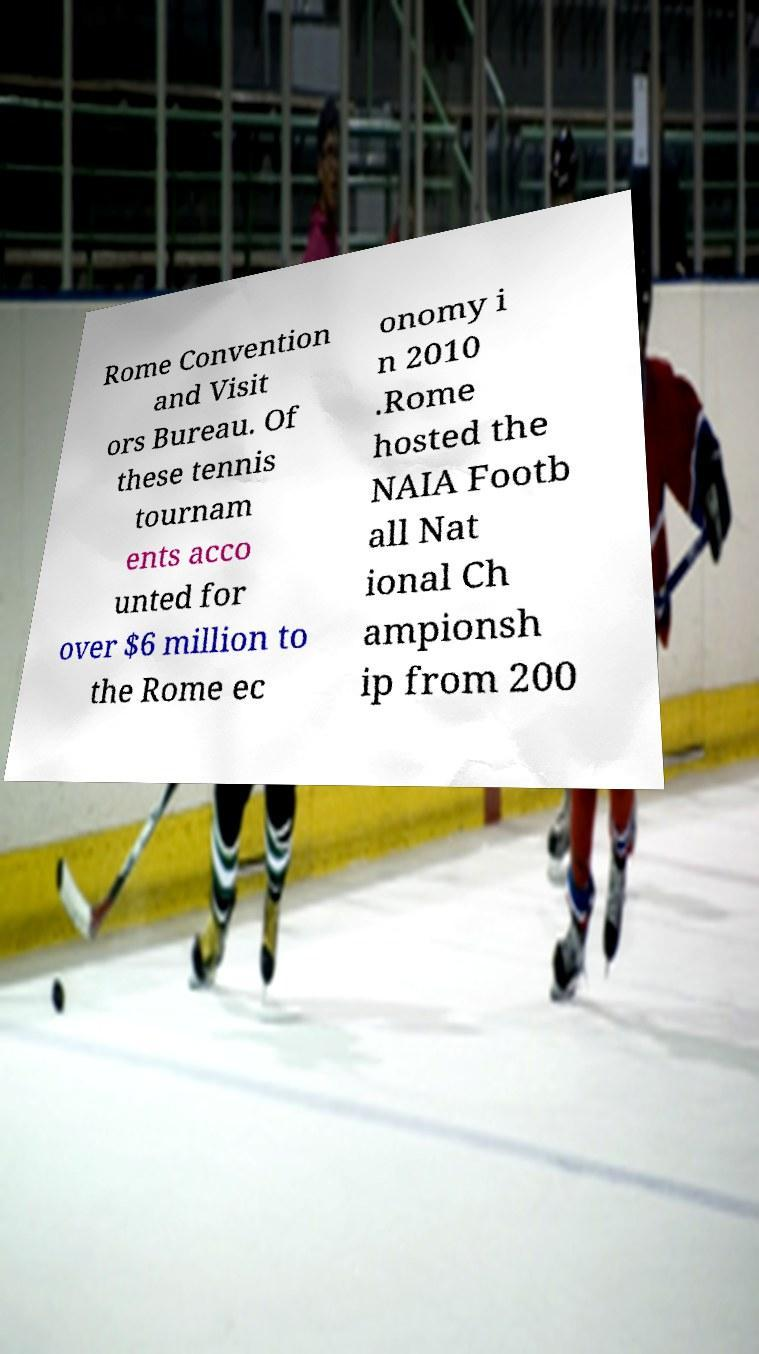What messages or text are displayed in this image? I need them in a readable, typed format. Rome Convention and Visit ors Bureau. Of these tennis tournam ents acco unted for over $6 million to the Rome ec onomy i n 2010 .Rome hosted the NAIA Footb all Nat ional Ch ampionsh ip from 200 